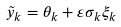Convert formula to latex. <formula><loc_0><loc_0><loc_500><loc_500>\tilde { y } _ { k } = \theta _ { k } + \varepsilon \sigma _ { k } \xi _ { k }</formula> 